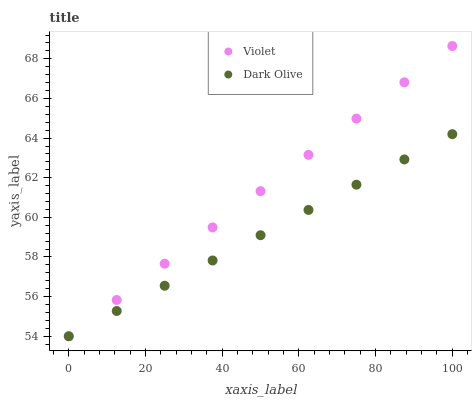Does Dark Olive have the minimum area under the curve?
Answer yes or no. Yes. Does Violet have the maximum area under the curve?
Answer yes or no. Yes. Does Violet have the minimum area under the curve?
Answer yes or no. No. Is Dark Olive the smoothest?
Answer yes or no. Yes. Is Violet the roughest?
Answer yes or no. Yes. Is Violet the smoothest?
Answer yes or no. No. Does Dark Olive have the lowest value?
Answer yes or no. Yes. Does Violet have the highest value?
Answer yes or no. Yes. Does Dark Olive intersect Violet?
Answer yes or no. Yes. Is Dark Olive less than Violet?
Answer yes or no. No. Is Dark Olive greater than Violet?
Answer yes or no. No. 